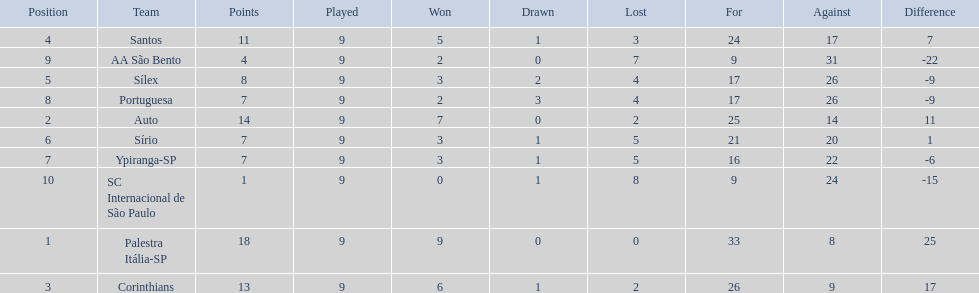What were the top three amounts of games won for 1926 in brazilian football season? 9, 7, 6. What were the top amount of games won for 1926 in brazilian football season? 9. What team won the top amount of games Palestra Itália-SP. 